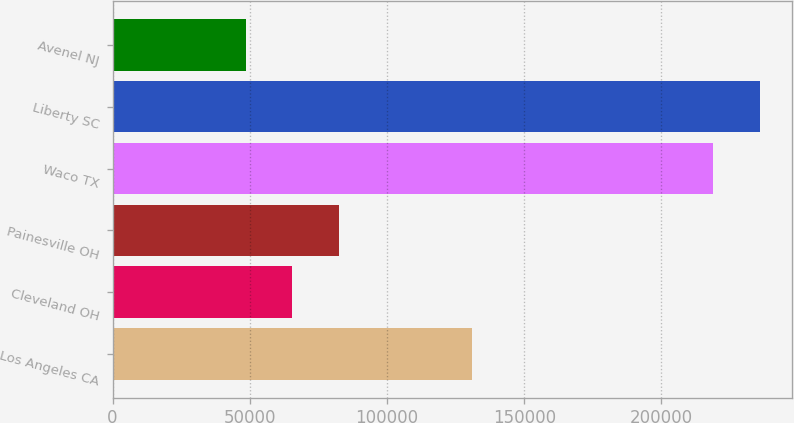Convert chart to OTSL. <chart><loc_0><loc_0><loc_500><loc_500><bar_chart><fcel>Los Angeles CA<fcel>Cleveland OH<fcel>Painesville OH<fcel>Waco TX<fcel>Liberty SC<fcel>Avenel NJ<nl><fcel>131000<fcel>65550<fcel>82600<fcel>218800<fcel>235850<fcel>48500<nl></chart> 